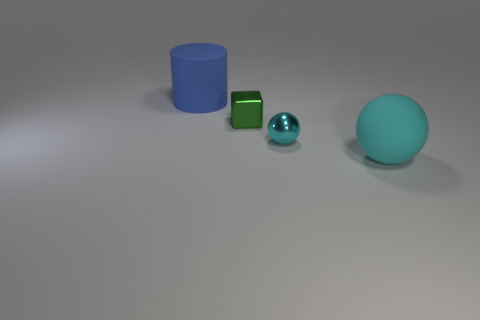What number of objects are spheres that are behind the matte sphere or objects right of the cylinder?
Offer a very short reply. 3. What is the material of the big blue cylinder that is behind the tiny object that is behind the small cyan metal ball?
Provide a short and direct response. Rubber. What number of other things are made of the same material as the blue cylinder?
Provide a short and direct response. 1. Is the cyan shiny thing the same shape as the blue object?
Give a very brief answer. No. How big is the sphere to the left of the cyan matte object?
Your answer should be very brief. Small. There is a cylinder; does it have the same size as the cyan object that is behind the big cyan sphere?
Offer a terse response. No. Is the number of big cyan matte things in front of the big sphere less than the number of large cyan rubber spheres?
Offer a terse response. Yes. There is a large cyan thing that is the same shape as the tiny cyan metal thing; what is its material?
Give a very brief answer. Rubber. The object that is both right of the blue matte object and to the left of the tiny sphere has what shape?
Your answer should be compact. Cube. What is the shape of the large blue object that is the same material as the large ball?
Offer a very short reply. Cylinder. 